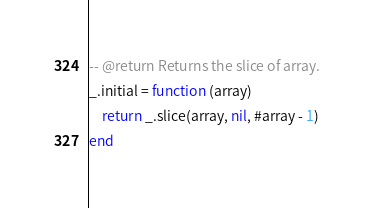Convert code to text. <code><loc_0><loc_0><loc_500><loc_500><_Lua_>-- @return Returns the slice of array.
_.initial = function (array)
    return _.slice(array, nil, #array - 1)
end
</code> 